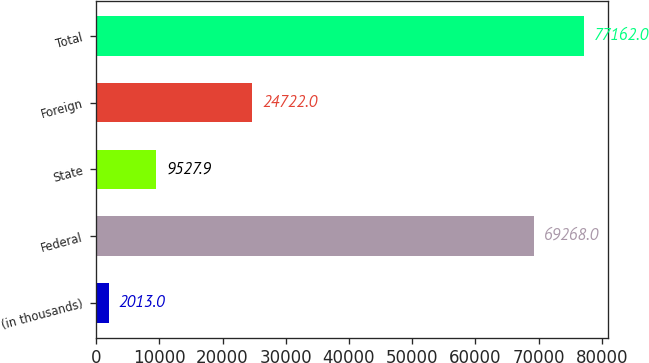Convert chart. <chart><loc_0><loc_0><loc_500><loc_500><bar_chart><fcel>(in thousands)<fcel>Federal<fcel>State<fcel>Foreign<fcel>Total<nl><fcel>2013<fcel>69268<fcel>9527.9<fcel>24722<fcel>77162<nl></chart> 